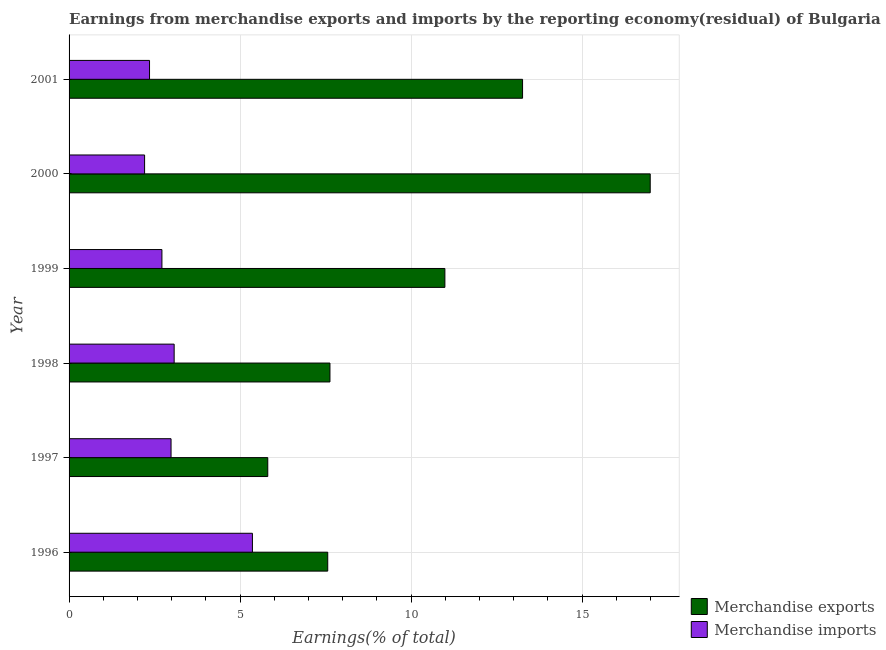Are the number of bars per tick equal to the number of legend labels?
Your answer should be very brief. Yes. What is the earnings from merchandise imports in 2000?
Your answer should be compact. 2.21. Across all years, what is the maximum earnings from merchandise imports?
Ensure brevity in your answer.  5.36. Across all years, what is the minimum earnings from merchandise imports?
Provide a short and direct response. 2.21. In which year was the earnings from merchandise imports maximum?
Offer a terse response. 1996. In which year was the earnings from merchandise exports minimum?
Ensure brevity in your answer.  1997. What is the total earnings from merchandise imports in the graph?
Keep it short and to the point. 18.69. What is the difference between the earnings from merchandise imports in 1996 and that in 1998?
Offer a very short reply. 2.29. What is the difference between the earnings from merchandise exports in 1999 and the earnings from merchandise imports in 2000?
Offer a terse response. 8.78. What is the average earnings from merchandise exports per year?
Offer a terse response. 10.37. In the year 2000, what is the difference between the earnings from merchandise imports and earnings from merchandise exports?
Keep it short and to the point. -14.78. In how many years, is the earnings from merchandise imports greater than 5 %?
Your response must be concise. 1. What is the ratio of the earnings from merchandise exports in 1998 to that in 2000?
Your answer should be compact. 0.45. Is the earnings from merchandise imports in 1998 less than that in 1999?
Give a very brief answer. No. What is the difference between the highest and the second highest earnings from merchandise exports?
Give a very brief answer. 3.73. What is the difference between the highest and the lowest earnings from merchandise imports?
Provide a short and direct response. 3.15. What does the 2nd bar from the bottom in 1999 represents?
Ensure brevity in your answer.  Merchandise imports. How many bars are there?
Keep it short and to the point. 12. Are all the bars in the graph horizontal?
Keep it short and to the point. Yes. What is the difference between two consecutive major ticks on the X-axis?
Offer a very short reply. 5. How many legend labels are there?
Make the answer very short. 2. What is the title of the graph?
Offer a very short reply. Earnings from merchandise exports and imports by the reporting economy(residual) of Bulgaria. Does "Net National savings" appear as one of the legend labels in the graph?
Provide a succinct answer. No. What is the label or title of the X-axis?
Provide a succinct answer. Earnings(% of total). What is the label or title of the Y-axis?
Provide a short and direct response. Year. What is the Earnings(% of total) of Merchandise exports in 1996?
Provide a short and direct response. 7.56. What is the Earnings(% of total) of Merchandise imports in 1996?
Make the answer very short. 5.36. What is the Earnings(% of total) of Merchandise exports in 1997?
Give a very brief answer. 5.81. What is the Earnings(% of total) of Merchandise imports in 1997?
Provide a short and direct response. 2.98. What is the Earnings(% of total) in Merchandise exports in 1998?
Your response must be concise. 7.63. What is the Earnings(% of total) in Merchandise imports in 1998?
Provide a succinct answer. 3.07. What is the Earnings(% of total) in Merchandise exports in 1999?
Ensure brevity in your answer.  10.99. What is the Earnings(% of total) of Merchandise imports in 1999?
Provide a succinct answer. 2.71. What is the Earnings(% of total) of Merchandise exports in 2000?
Provide a short and direct response. 16.99. What is the Earnings(% of total) in Merchandise imports in 2000?
Provide a succinct answer. 2.21. What is the Earnings(% of total) of Merchandise exports in 2001?
Your answer should be compact. 13.26. What is the Earnings(% of total) of Merchandise imports in 2001?
Provide a succinct answer. 2.35. Across all years, what is the maximum Earnings(% of total) in Merchandise exports?
Your response must be concise. 16.99. Across all years, what is the maximum Earnings(% of total) in Merchandise imports?
Your answer should be very brief. 5.36. Across all years, what is the minimum Earnings(% of total) of Merchandise exports?
Provide a succinct answer. 5.81. Across all years, what is the minimum Earnings(% of total) in Merchandise imports?
Your answer should be compact. 2.21. What is the total Earnings(% of total) of Merchandise exports in the graph?
Provide a succinct answer. 62.23. What is the total Earnings(% of total) of Merchandise imports in the graph?
Provide a short and direct response. 18.69. What is the difference between the Earnings(% of total) of Merchandise exports in 1996 and that in 1997?
Your answer should be compact. 1.75. What is the difference between the Earnings(% of total) in Merchandise imports in 1996 and that in 1997?
Ensure brevity in your answer.  2.38. What is the difference between the Earnings(% of total) of Merchandise exports in 1996 and that in 1998?
Your response must be concise. -0.06. What is the difference between the Earnings(% of total) of Merchandise imports in 1996 and that in 1998?
Provide a short and direct response. 2.29. What is the difference between the Earnings(% of total) of Merchandise exports in 1996 and that in 1999?
Provide a succinct answer. -3.42. What is the difference between the Earnings(% of total) of Merchandise imports in 1996 and that in 1999?
Provide a succinct answer. 2.65. What is the difference between the Earnings(% of total) in Merchandise exports in 1996 and that in 2000?
Your answer should be very brief. -9.43. What is the difference between the Earnings(% of total) of Merchandise imports in 1996 and that in 2000?
Give a very brief answer. 3.15. What is the difference between the Earnings(% of total) of Merchandise exports in 1996 and that in 2001?
Give a very brief answer. -5.7. What is the difference between the Earnings(% of total) in Merchandise imports in 1996 and that in 2001?
Provide a short and direct response. 3.01. What is the difference between the Earnings(% of total) of Merchandise exports in 1997 and that in 1998?
Give a very brief answer. -1.82. What is the difference between the Earnings(% of total) in Merchandise imports in 1997 and that in 1998?
Give a very brief answer. -0.09. What is the difference between the Earnings(% of total) of Merchandise exports in 1997 and that in 1999?
Your answer should be very brief. -5.18. What is the difference between the Earnings(% of total) in Merchandise imports in 1997 and that in 1999?
Provide a short and direct response. 0.27. What is the difference between the Earnings(% of total) in Merchandise exports in 1997 and that in 2000?
Provide a short and direct response. -11.18. What is the difference between the Earnings(% of total) in Merchandise imports in 1997 and that in 2000?
Your answer should be compact. 0.77. What is the difference between the Earnings(% of total) of Merchandise exports in 1997 and that in 2001?
Your answer should be compact. -7.45. What is the difference between the Earnings(% of total) of Merchandise imports in 1997 and that in 2001?
Provide a short and direct response. 0.63. What is the difference between the Earnings(% of total) of Merchandise exports in 1998 and that in 1999?
Offer a terse response. -3.36. What is the difference between the Earnings(% of total) in Merchandise imports in 1998 and that in 1999?
Give a very brief answer. 0.36. What is the difference between the Earnings(% of total) in Merchandise exports in 1998 and that in 2000?
Provide a succinct answer. -9.36. What is the difference between the Earnings(% of total) of Merchandise imports in 1998 and that in 2000?
Your answer should be very brief. 0.86. What is the difference between the Earnings(% of total) of Merchandise exports in 1998 and that in 2001?
Make the answer very short. -5.63. What is the difference between the Earnings(% of total) in Merchandise imports in 1998 and that in 2001?
Offer a terse response. 0.72. What is the difference between the Earnings(% of total) in Merchandise exports in 1999 and that in 2000?
Your response must be concise. -6. What is the difference between the Earnings(% of total) of Merchandise imports in 1999 and that in 2000?
Make the answer very short. 0.51. What is the difference between the Earnings(% of total) of Merchandise exports in 1999 and that in 2001?
Keep it short and to the point. -2.27. What is the difference between the Earnings(% of total) of Merchandise imports in 1999 and that in 2001?
Keep it short and to the point. 0.36. What is the difference between the Earnings(% of total) of Merchandise exports in 2000 and that in 2001?
Provide a short and direct response. 3.73. What is the difference between the Earnings(% of total) in Merchandise imports in 2000 and that in 2001?
Ensure brevity in your answer.  -0.14. What is the difference between the Earnings(% of total) of Merchandise exports in 1996 and the Earnings(% of total) of Merchandise imports in 1997?
Offer a terse response. 4.58. What is the difference between the Earnings(% of total) in Merchandise exports in 1996 and the Earnings(% of total) in Merchandise imports in 1998?
Ensure brevity in your answer.  4.49. What is the difference between the Earnings(% of total) of Merchandise exports in 1996 and the Earnings(% of total) of Merchandise imports in 1999?
Keep it short and to the point. 4.85. What is the difference between the Earnings(% of total) in Merchandise exports in 1996 and the Earnings(% of total) in Merchandise imports in 2000?
Keep it short and to the point. 5.35. What is the difference between the Earnings(% of total) of Merchandise exports in 1996 and the Earnings(% of total) of Merchandise imports in 2001?
Your answer should be very brief. 5.21. What is the difference between the Earnings(% of total) in Merchandise exports in 1997 and the Earnings(% of total) in Merchandise imports in 1998?
Provide a short and direct response. 2.74. What is the difference between the Earnings(% of total) of Merchandise exports in 1997 and the Earnings(% of total) of Merchandise imports in 1999?
Your answer should be compact. 3.09. What is the difference between the Earnings(% of total) in Merchandise exports in 1997 and the Earnings(% of total) in Merchandise imports in 2000?
Your answer should be compact. 3.6. What is the difference between the Earnings(% of total) in Merchandise exports in 1997 and the Earnings(% of total) in Merchandise imports in 2001?
Your answer should be compact. 3.46. What is the difference between the Earnings(% of total) in Merchandise exports in 1998 and the Earnings(% of total) in Merchandise imports in 1999?
Give a very brief answer. 4.91. What is the difference between the Earnings(% of total) in Merchandise exports in 1998 and the Earnings(% of total) in Merchandise imports in 2000?
Keep it short and to the point. 5.42. What is the difference between the Earnings(% of total) in Merchandise exports in 1998 and the Earnings(% of total) in Merchandise imports in 2001?
Keep it short and to the point. 5.27. What is the difference between the Earnings(% of total) of Merchandise exports in 1999 and the Earnings(% of total) of Merchandise imports in 2000?
Give a very brief answer. 8.78. What is the difference between the Earnings(% of total) of Merchandise exports in 1999 and the Earnings(% of total) of Merchandise imports in 2001?
Offer a very short reply. 8.63. What is the difference between the Earnings(% of total) in Merchandise exports in 2000 and the Earnings(% of total) in Merchandise imports in 2001?
Provide a short and direct response. 14.64. What is the average Earnings(% of total) in Merchandise exports per year?
Your answer should be compact. 10.37. What is the average Earnings(% of total) in Merchandise imports per year?
Provide a succinct answer. 3.11. In the year 1996, what is the difference between the Earnings(% of total) of Merchandise exports and Earnings(% of total) of Merchandise imports?
Give a very brief answer. 2.2. In the year 1997, what is the difference between the Earnings(% of total) of Merchandise exports and Earnings(% of total) of Merchandise imports?
Ensure brevity in your answer.  2.83. In the year 1998, what is the difference between the Earnings(% of total) in Merchandise exports and Earnings(% of total) in Merchandise imports?
Your answer should be compact. 4.55. In the year 1999, what is the difference between the Earnings(% of total) of Merchandise exports and Earnings(% of total) of Merchandise imports?
Offer a very short reply. 8.27. In the year 2000, what is the difference between the Earnings(% of total) in Merchandise exports and Earnings(% of total) in Merchandise imports?
Make the answer very short. 14.78. In the year 2001, what is the difference between the Earnings(% of total) of Merchandise exports and Earnings(% of total) of Merchandise imports?
Offer a very short reply. 10.91. What is the ratio of the Earnings(% of total) of Merchandise exports in 1996 to that in 1997?
Keep it short and to the point. 1.3. What is the ratio of the Earnings(% of total) of Merchandise imports in 1996 to that in 1997?
Your response must be concise. 1.8. What is the ratio of the Earnings(% of total) in Merchandise exports in 1996 to that in 1998?
Your answer should be very brief. 0.99. What is the ratio of the Earnings(% of total) of Merchandise imports in 1996 to that in 1998?
Your response must be concise. 1.74. What is the ratio of the Earnings(% of total) in Merchandise exports in 1996 to that in 1999?
Give a very brief answer. 0.69. What is the ratio of the Earnings(% of total) in Merchandise imports in 1996 to that in 1999?
Offer a very short reply. 1.97. What is the ratio of the Earnings(% of total) in Merchandise exports in 1996 to that in 2000?
Provide a succinct answer. 0.45. What is the ratio of the Earnings(% of total) in Merchandise imports in 1996 to that in 2000?
Keep it short and to the point. 2.43. What is the ratio of the Earnings(% of total) of Merchandise exports in 1996 to that in 2001?
Your answer should be very brief. 0.57. What is the ratio of the Earnings(% of total) in Merchandise imports in 1996 to that in 2001?
Offer a terse response. 2.28. What is the ratio of the Earnings(% of total) in Merchandise exports in 1997 to that in 1998?
Provide a short and direct response. 0.76. What is the ratio of the Earnings(% of total) in Merchandise imports in 1997 to that in 1998?
Provide a short and direct response. 0.97. What is the ratio of the Earnings(% of total) of Merchandise exports in 1997 to that in 1999?
Ensure brevity in your answer.  0.53. What is the ratio of the Earnings(% of total) of Merchandise imports in 1997 to that in 1999?
Ensure brevity in your answer.  1.1. What is the ratio of the Earnings(% of total) in Merchandise exports in 1997 to that in 2000?
Provide a succinct answer. 0.34. What is the ratio of the Earnings(% of total) in Merchandise imports in 1997 to that in 2000?
Keep it short and to the point. 1.35. What is the ratio of the Earnings(% of total) of Merchandise exports in 1997 to that in 2001?
Provide a short and direct response. 0.44. What is the ratio of the Earnings(% of total) in Merchandise imports in 1997 to that in 2001?
Keep it short and to the point. 1.27. What is the ratio of the Earnings(% of total) of Merchandise exports in 1998 to that in 1999?
Offer a terse response. 0.69. What is the ratio of the Earnings(% of total) in Merchandise imports in 1998 to that in 1999?
Your response must be concise. 1.13. What is the ratio of the Earnings(% of total) in Merchandise exports in 1998 to that in 2000?
Your answer should be compact. 0.45. What is the ratio of the Earnings(% of total) in Merchandise imports in 1998 to that in 2000?
Offer a very short reply. 1.39. What is the ratio of the Earnings(% of total) in Merchandise exports in 1998 to that in 2001?
Offer a terse response. 0.58. What is the ratio of the Earnings(% of total) in Merchandise imports in 1998 to that in 2001?
Offer a very short reply. 1.31. What is the ratio of the Earnings(% of total) of Merchandise exports in 1999 to that in 2000?
Provide a short and direct response. 0.65. What is the ratio of the Earnings(% of total) of Merchandise imports in 1999 to that in 2000?
Give a very brief answer. 1.23. What is the ratio of the Earnings(% of total) of Merchandise exports in 1999 to that in 2001?
Make the answer very short. 0.83. What is the ratio of the Earnings(% of total) of Merchandise imports in 1999 to that in 2001?
Offer a terse response. 1.15. What is the ratio of the Earnings(% of total) of Merchandise exports in 2000 to that in 2001?
Offer a very short reply. 1.28. What is the ratio of the Earnings(% of total) in Merchandise imports in 2000 to that in 2001?
Give a very brief answer. 0.94. What is the difference between the highest and the second highest Earnings(% of total) of Merchandise exports?
Offer a very short reply. 3.73. What is the difference between the highest and the second highest Earnings(% of total) of Merchandise imports?
Your answer should be compact. 2.29. What is the difference between the highest and the lowest Earnings(% of total) of Merchandise exports?
Offer a very short reply. 11.18. What is the difference between the highest and the lowest Earnings(% of total) in Merchandise imports?
Provide a succinct answer. 3.15. 